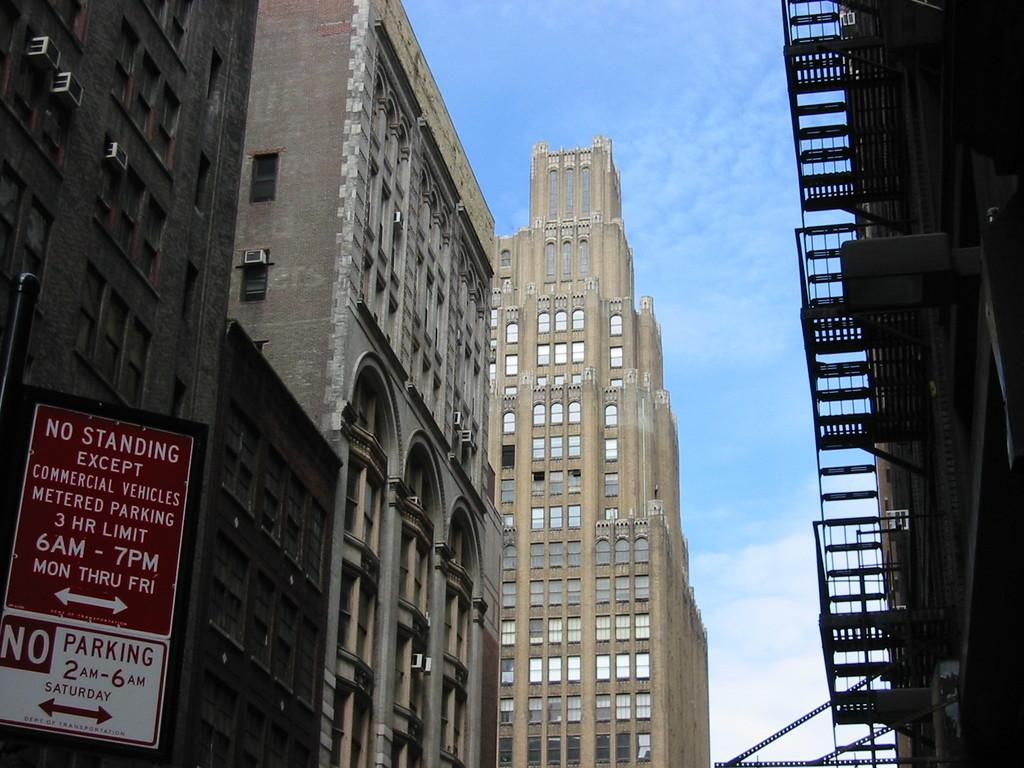What is located on the left side of the image? There is a sign board and buildings with windows on the left side of the image. Can you describe the building on the right side of the image? There is a building on the right side of the image. What can be seen in the background of the image? There are clouds in the blue sky in the background of the image. What type of pencil can be seen in the image? There is no pencil present in the image. Is there any grass visible in the image? There is no grass visible in the image; it features buildings and a sign board. 